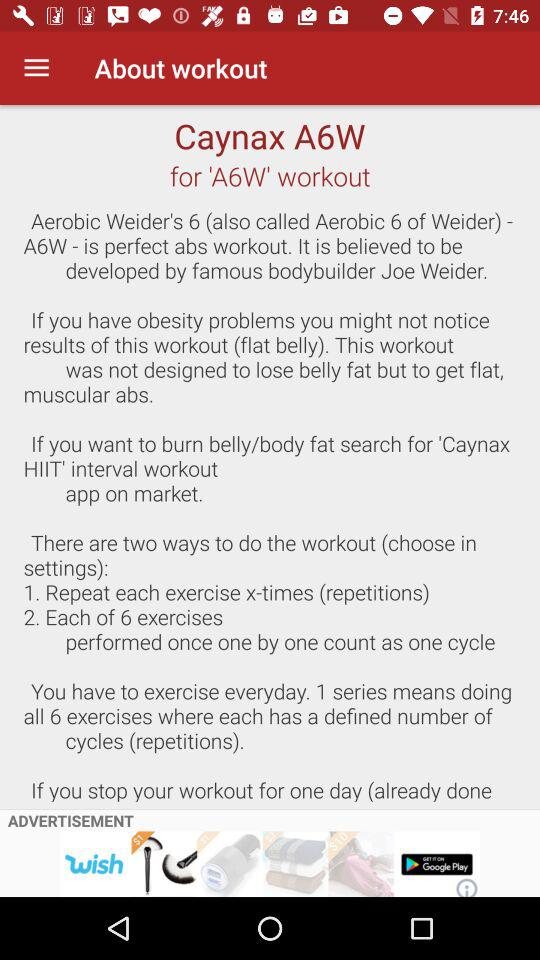What is the application name? The name is "Caynax A6W". 